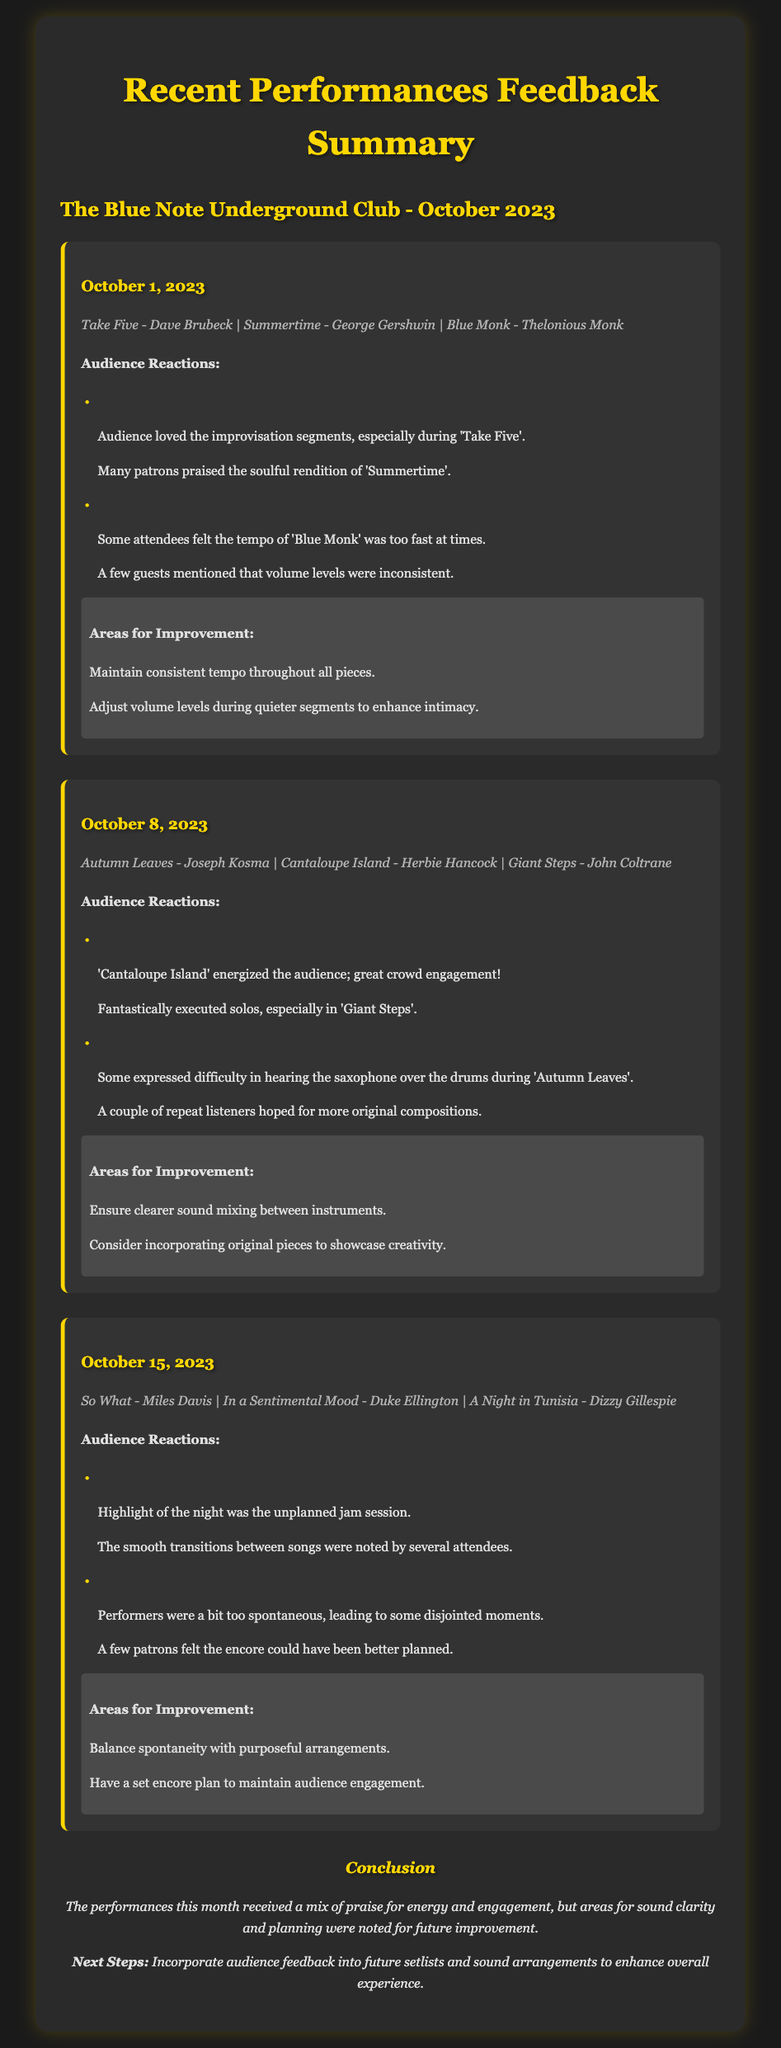What date did the performance at The Blue Note Underground Club take place? The date for the performance is mentioned at the top of the section for each performance. The first performance is on October 1, 2023.
Answer: October 1, 2023 What was the setlist for the performance on October 8, 2023? The setlist is given under each performance section; for October 8, 2023, it lists the songs played. The songs were Autumn Leaves, Cantaloupe Island, and Giant Steps.
Answer: Autumn Leaves - Cantaloupe Island - Giant Steps Which song received positive feedback for its solos on October 8? The document states that the audience specifically praised the solos executed in 'Giant Steps.'
Answer: Giant Steps What was a noted area for improvement from the performance on October 15? The document lists areas for improvement; one of the points from October 15 was about balancing spontaneity with purposeful arrangements.
Answer: Balance spontaneity with purposeful arrangements What did the audience particularly enjoy about 'Take Five'? The document indicates that audience loved the improvisation segments during 'Take Five.'
Answer: Improvisation segments 